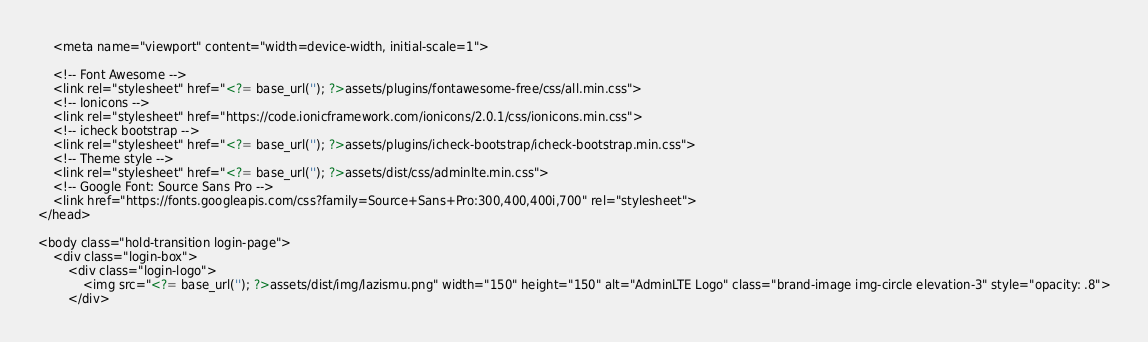Convert code to text. <code><loc_0><loc_0><loc_500><loc_500><_PHP_>    <meta name="viewport" content="width=device-width, initial-scale=1">

    <!-- Font Awesome -->
    <link rel="stylesheet" href="<?= base_url(''); ?>assets/plugins/fontawesome-free/css/all.min.css">
    <!-- Ionicons -->
    <link rel="stylesheet" href="https://code.ionicframework.com/ionicons/2.0.1/css/ionicons.min.css">
    <!-- icheck bootstrap -->
    <link rel="stylesheet" href="<?= base_url(''); ?>assets/plugins/icheck-bootstrap/icheck-bootstrap.min.css">
    <!-- Theme style -->
    <link rel="stylesheet" href="<?= base_url(''); ?>assets/dist/css/adminlte.min.css">
    <!-- Google Font: Source Sans Pro -->
    <link href="https://fonts.googleapis.com/css?family=Source+Sans+Pro:300,400,400i,700" rel="stylesheet">
</head>

<body class="hold-transition login-page">
    <div class="login-box">
        <div class="login-logo">
            <img src="<?= base_url(''); ?>assets/dist/img/lazismu.png" width="150" height="150" alt="AdminLTE Logo" class="brand-image img-circle elevation-3" style="opacity: .8">
        </div></code> 